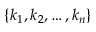<formula> <loc_0><loc_0><loc_500><loc_500>\{ k _ { 1 } , k _ { 2 } , \dots , k _ { n } \}</formula> 